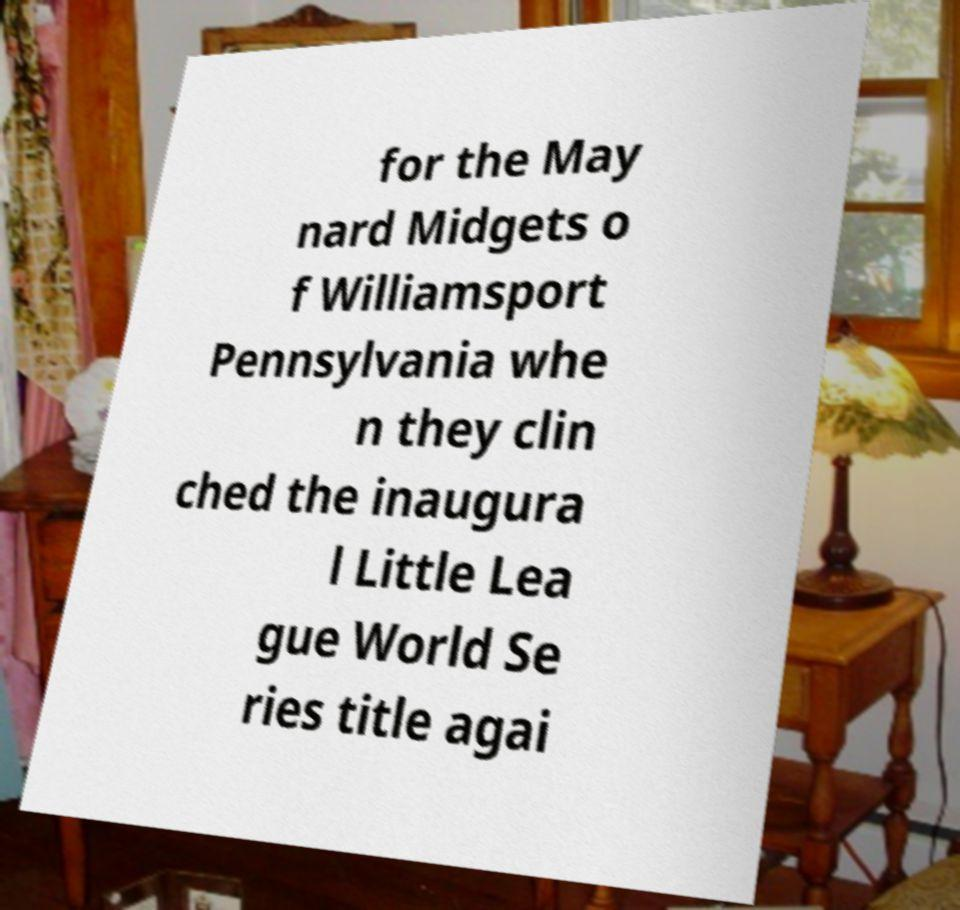There's text embedded in this image that I need extracted. Can you transcribe it verbatim? for the May nard Midgets o f Williamsport Pennsylvania whe n they clin ched the inaugura l Little Lea gue World Se ries title agai 